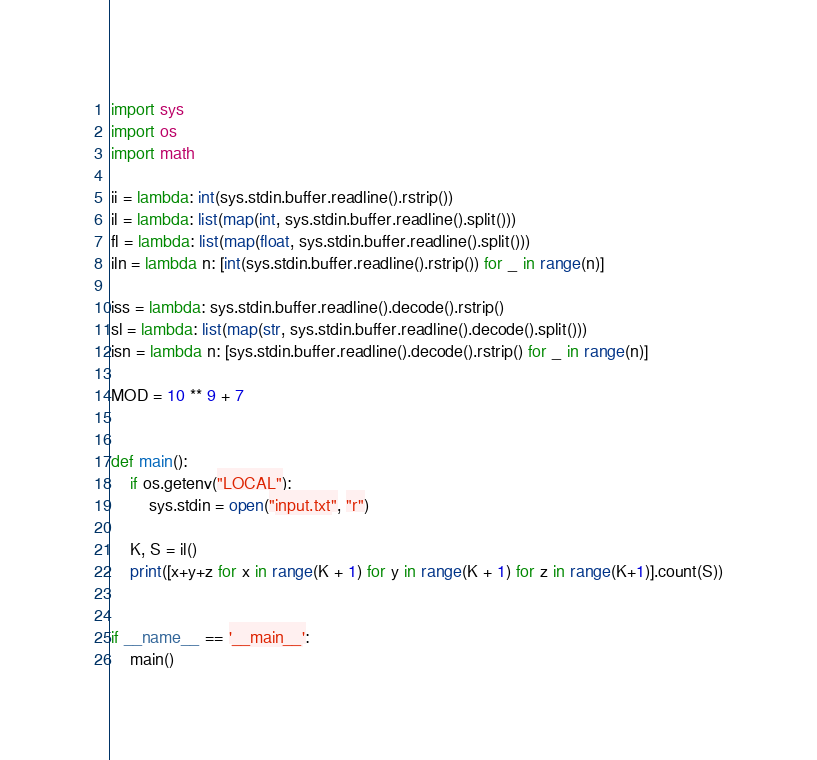Convert code to text. <code><loc_0><loc_0><loc_500><loc_500><_Python_>import sys
import os
import math

ii = lambda: int(sys.stdin.buffer.readline().rstrip())
il = lambda: list(map(int, sys.stdin.buffer.readline().split()))
fl = lambda: list(map(float, sys.stdin.buffer.readline().split()))
iln = lambda n: [int(sys.stdin.buffer.readline().rstrip()) for _ in range(n)]

iss = lambda: sys.stdin.buffer.readline().decode().rstrip()
sl = lambda: list(map(str, sys.stdin.buffer.readline().decode().split()))
isn = lambda n: [sys.stdin.buffer.readline().decode().rstrip() for _ in range(n)]

MOD = 10 ** 9 + 7


def main():
    if os.getenv("LOCAL"):
        sys.stdin = open("input.txt", "r")

    K, S = il()
    print([x+y+z for x in range(K + 1) for y in range(K + 1) for z in range(K+1)].count(S))


if __name__ == '__main__':
    main()
</code> 